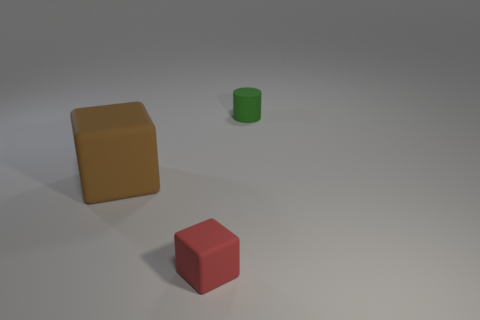How many yellow blocks are made of the same material as the small cylinder? Upon reviewing the image, there are no yellow blocks present. Therefore, it's not possible for any yellow blocks to be made of the same material as the small cylinder, which appears to be green. 